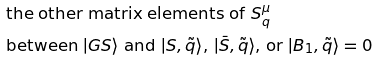Convert formula to latex. <formula><loc_0><loc_0><loc_500><loc_500>& \text {the other matrix elements of $S^{\mu}_{q}$} \\ & \text {between $|GS\rangle$ and $|S, \tilde{q} \rangle$, $|\bar{S}, \tilde{q} \rangle$, or $|B_{1}, \tilde{q} \rangle$} = 0</formula> 